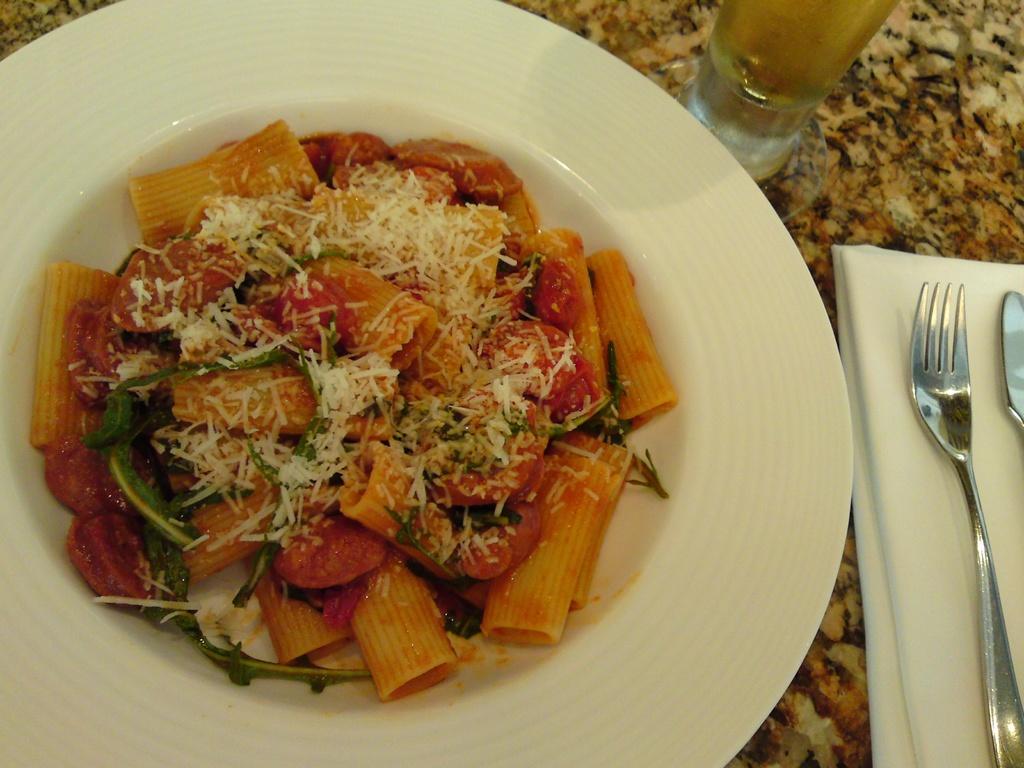Can you describe this image briefly? In the center of the image there is a food item in a plate. To the right side of the image there is a fork spoon,tissue. There is a glass on the table. 